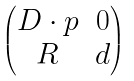Convert formula to latex. <formula><loc_0><loc_0><loc_500><loc_500>\begin{pmatrix} D \cdot p & 0 \\ R & d \end{pmatrix}</formula> 